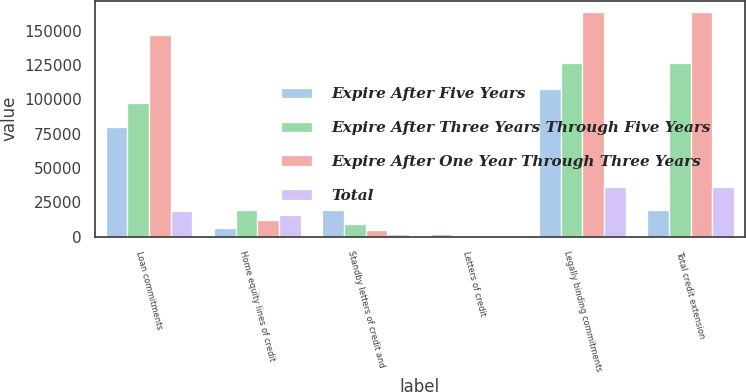Convert chart. <chart><loc_0><loc_0><loc_500><loc_500><stacked_bar_chart><ecel><fcel>Loan commitments<fcel>Home equity lines of credit<fcel>Standby letters of credit and<fcel>Letters of credit<fcel>Legally binding commitments<fcel>Total credit extension<nl><fcel>Expire After Five Years<fcel>79897<fcel>6292<fcel>19259<fcel>1883<fcel>107331<fcel>19259<nl><fcel>Expire After Three Years Through Five Years<fcel>97583<fcel>19679<fcel>9106<fcel>157<fcel>126525<fcel>126525<nl><fcel>Expire After One Year Through Three Years<fcel>146743<fcel>12319<fcel>4519<fcel>35<fcel>163616<fcel>163616<nl><fcel>Total<fcel>18942<fcel>15417<fcel>1807<fcel>88<fcel>36254<fcel>36254<nl></chart> 